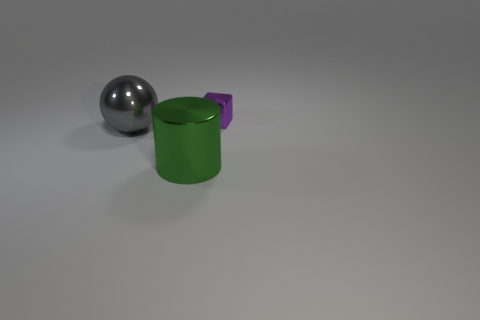Add 2 small purple rubber balls. How many objects exist? 5 Subtract all cubes. How many objects are left? 2 Add 3 green metallic things. How many green metallic things are left? 4 Add 3 big cylinders. How many big cylinders exist? 4 Subtract 0 green balls. How many objects are left? 3 Subtract all small objects. Subtract all large gray balls. How many objects are left? 1 